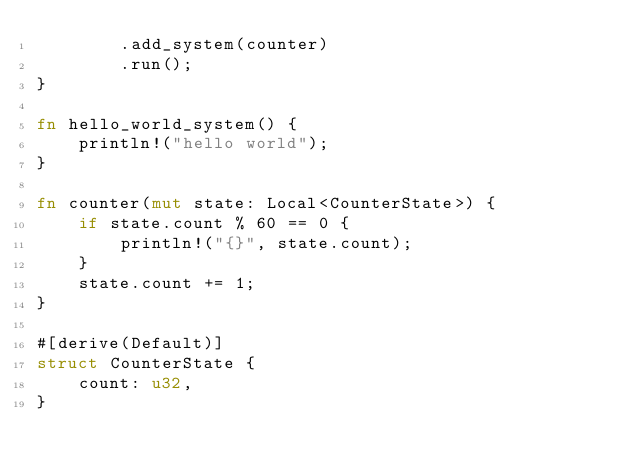<code> <loc_0><loc_0><loc_500><loc_500><_Rust_>        .add_system(counter)
        .run();
}

fn hello_world_system() {
    println!("hello world");
}

fn counter(mut state: Local<CounterState>) {
    if state.count % 60 == 0 {
        println!("{}", state.count);
    }
    state.count += 1;
}

#[derive(Default)]
struct CounterState {
    count: u32,
}
</code> 